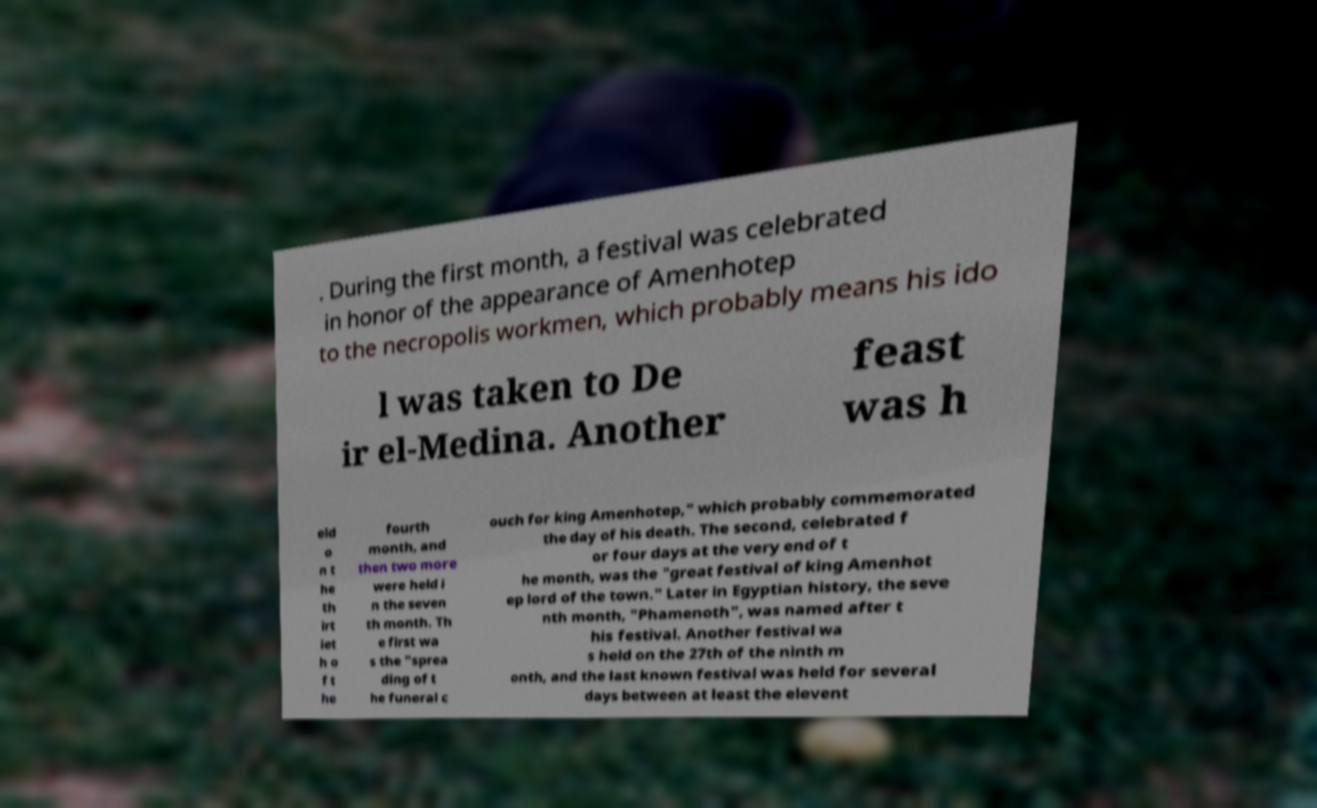Can you read and provide the text displayed in the image?This photo seems to have some interesting text. Can you extract and type it out for me? . During the first month, a festival was celebrated in honor of the appearance of Amenhotep to the necropolis workmen, which probably means his ido l was taken to De ir el-Medina. Another feast was h eld o n t he th irt iet h o f t he fourth month, and then two more were held i n the seven th month. Th e first wa s the "sprea ding of t he funeral c ouch for king Amenhotep," which probably commemorated the day of his death. The second, celebrated f or four days at the very end of t he month, was the "great festival of king Amenhot ep lord of the town." Later in Egyptian history, the seve nth month, "Phamenoth", was named after t his festival. Another festival wa s held on the 27th of the ninth m onth, and the last known festival was held for several days between at least the elevent 